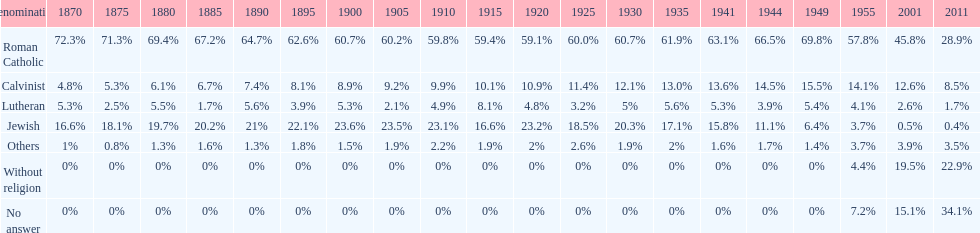In which year was the percentage of those without religion at least 20%? 2011. 